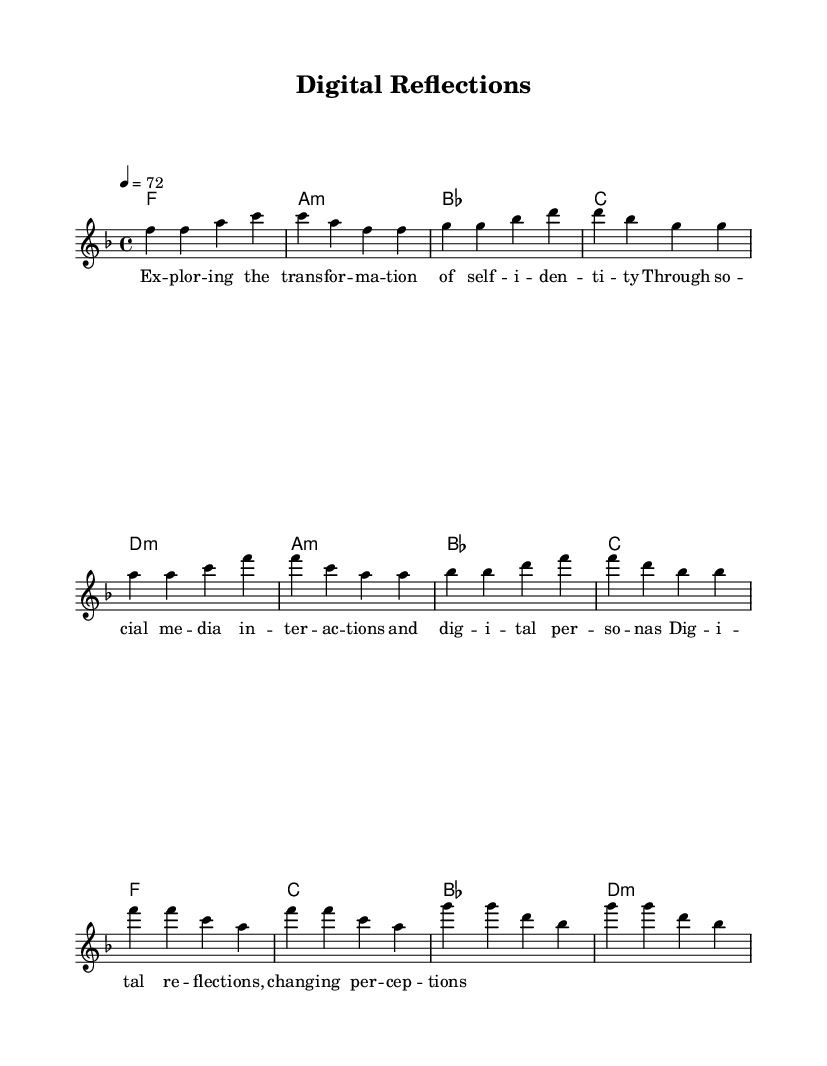What is the key signature of this music? The key signature is indicated at the beginning of the score, showing one flat (B), which means it is in F major.
Answer: F major What is the time signature of this music? The time signature is shown right after the key signature, indicating that there are four beats in each measure, represented by the 4/4 time signature.
Answer: 4/4 What is the tempo marking for this piece? The tempo marking is located at the start of the score, showing a metronome mark of 72 beats per minute, meaning it should be played at a moderate pace.
Answer: 72 How many measures are in the melody? By counting the individual groups of notes separated by vertical lines, there are a total of 12 measures in the melody section.
Answer: 12 What section follows the verse in this piece? The structure of the score indicates that the pre-chorus follows the verse section, which is established by the different sets of chords and melody provided in the score.
Answer: Pre-Chorus What type of chord is used in the chorus? The chorus section prominently features F major and D minor chords, which are typical in pop music for creating an emotional impact.
Answer: F major and D minor What theme is reflected in the lyrics of this ballad? The lyrics reflect on personal identity and the influence of social media, as indicated by phrases regarding transformation and digital interactions.
Answer: Personal identity 